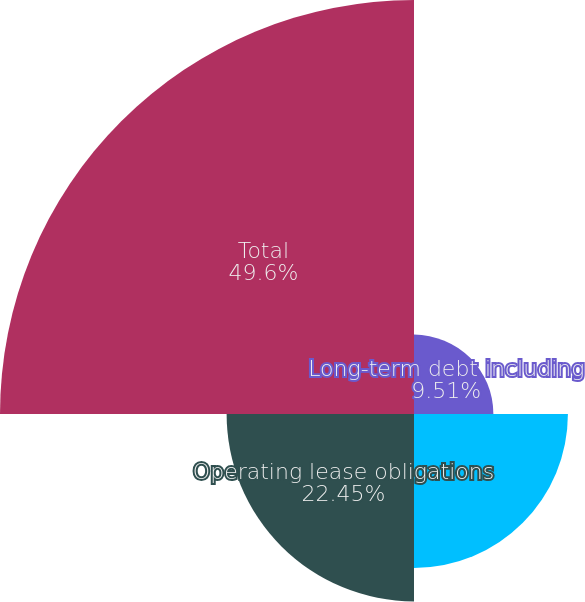<chart> <loc_0><loc_0><loc_500><loc_500><pie_chart><fcel>Long-term debt including<fcel>Inventory purchase commitments<fcel>Operating lease obligations<fcel>Total<nl><fcel>9.51%<fcel>18.44%<fcel>22.45%<fcel>49.6%<nl></chart> 